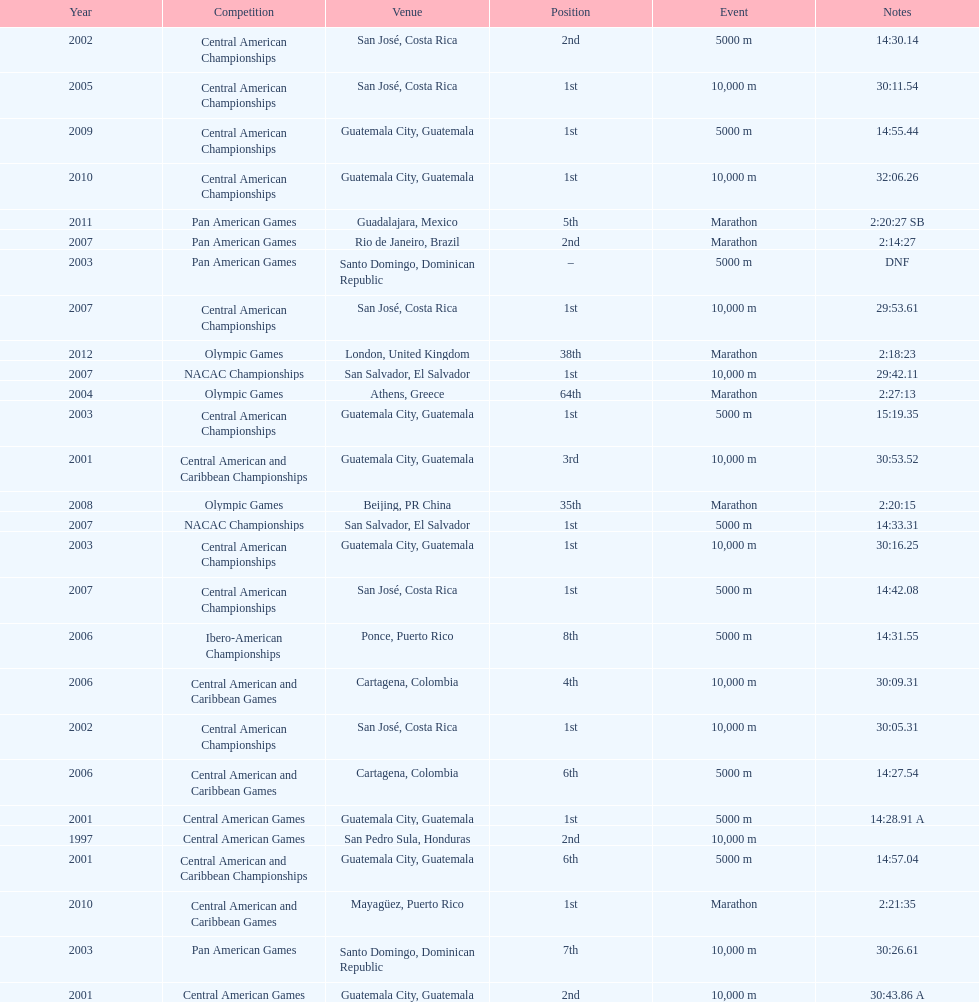The central american championships and what other competition occurred in 2010? Central American and Caribbean Games. 